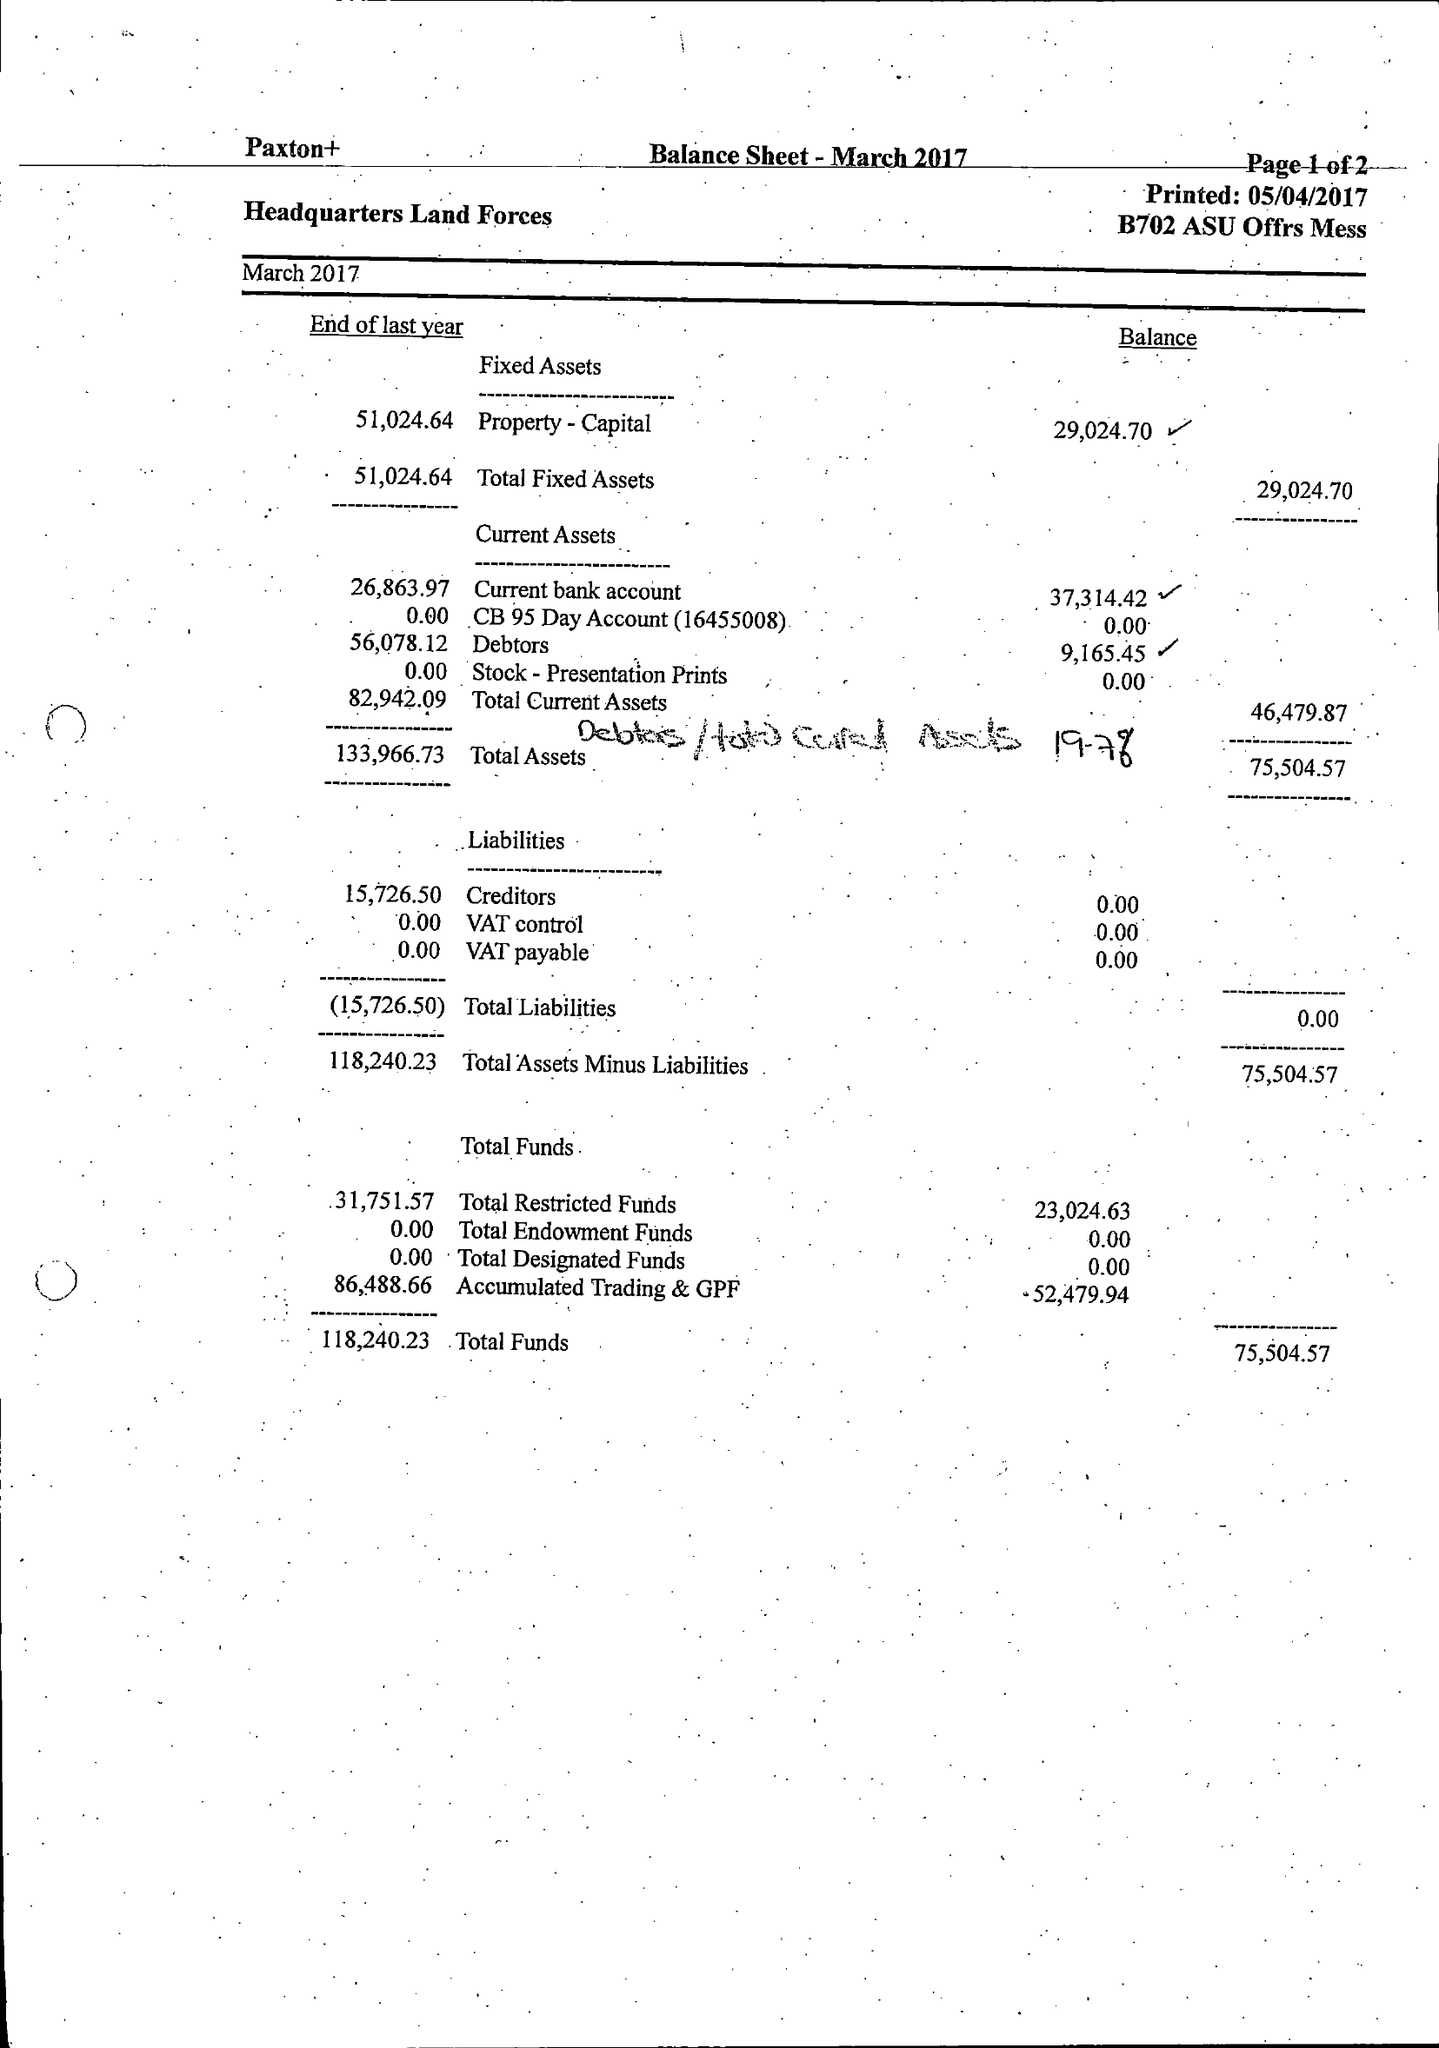What is the value for the address__street_line?
Answer the question using a single word or phrase. MONXTON ROAD 